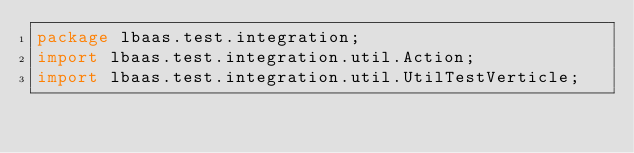<code> <loc_0><loc_0><loc_500><loc_500><_Java_>package lbaas.test.integration;
import lbaas.test.integration.util.Action;
import lbaas.test.integration.util.UtilTestVerticle;
</code> 